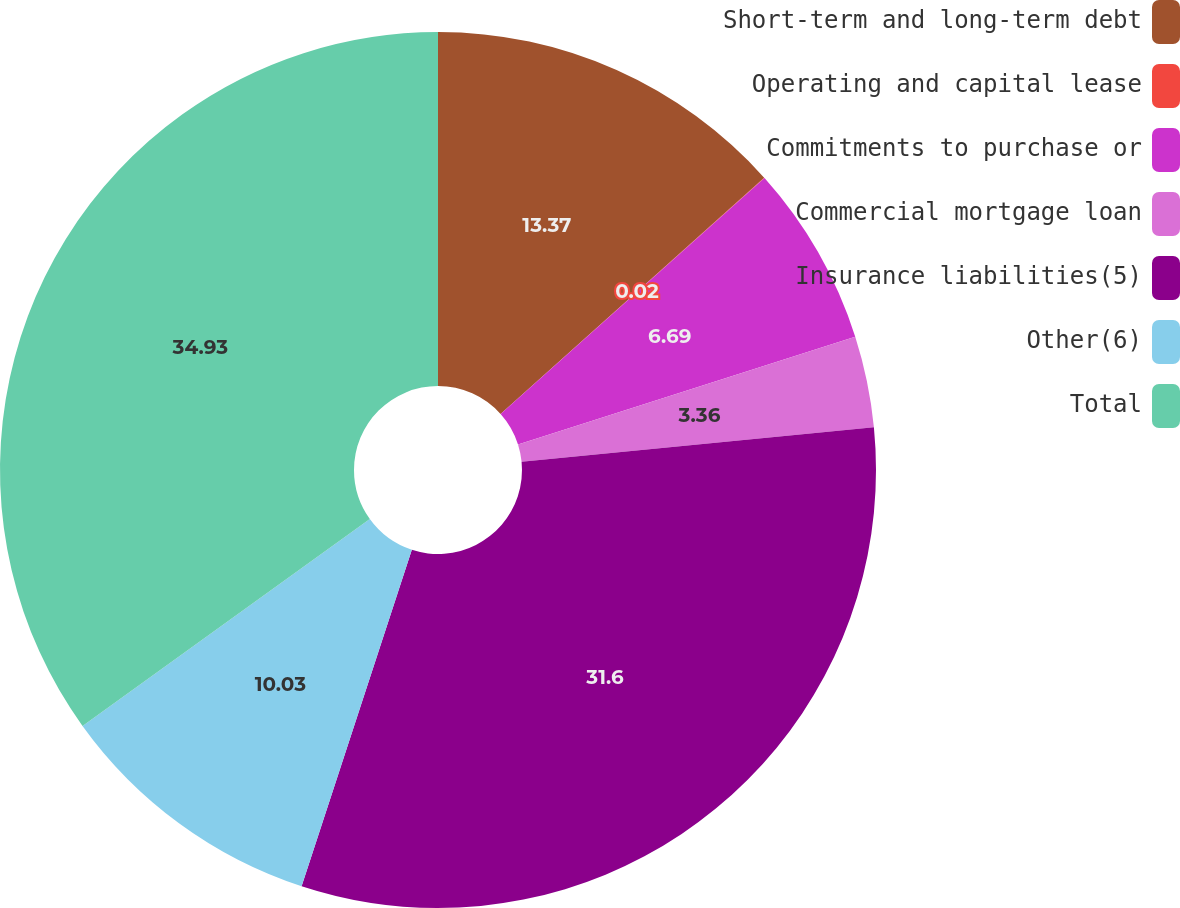<chart> <loc_0><loc_0><loc_500><loc_500><pie_chart><fcel>Short-term and long-term debt<fcel>Operating and capital lease<fcel>Commitments to purchase or<fcel>Commercial mortgage loan<fcel>Insurance liabilities(5)<fcel>Other(6)<fcel>Total<nl><fcel>13.37%<fcel>0.02%<fcel>6.69%<fcel>3.36%<fcel>31.6%<fcel>10.03%<fcel>34.93%<nl></chart> 